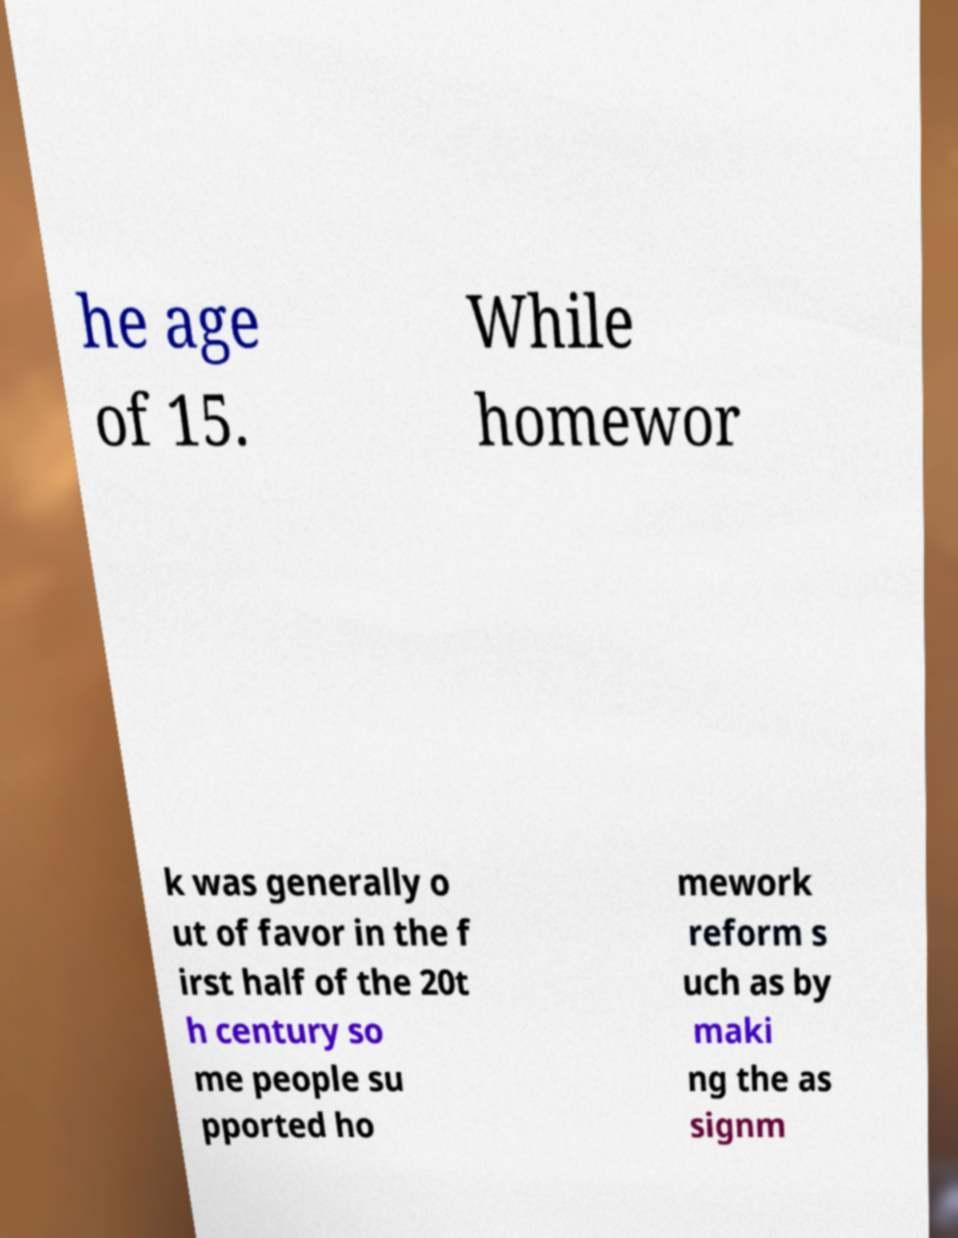What messages or text are displayed in this image? I need them in a readable, typed format. he age of 15. While homewor k was generally o ut of favor in the f irst half of the 20t h century so me people su pported ho mework reform s uch as by maki ng the as signm 